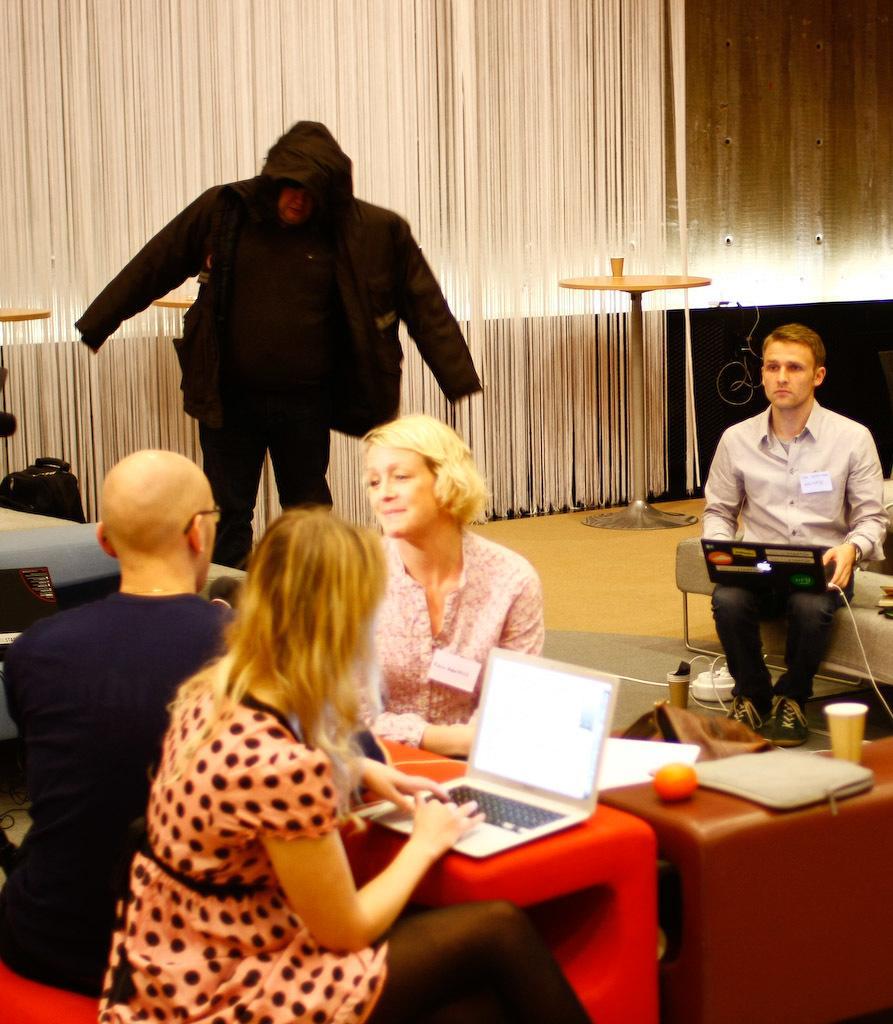How would you summarize this image in a sentence or two? In this image there are persons sitting and standing. In the front there is a woman sitting and working on a laptop and in the center there is a table, on the table there is a fruit and there is a file and a glass. In the background there is a stand and on the stand there is a glass and there is a curtain which is white in colour. 